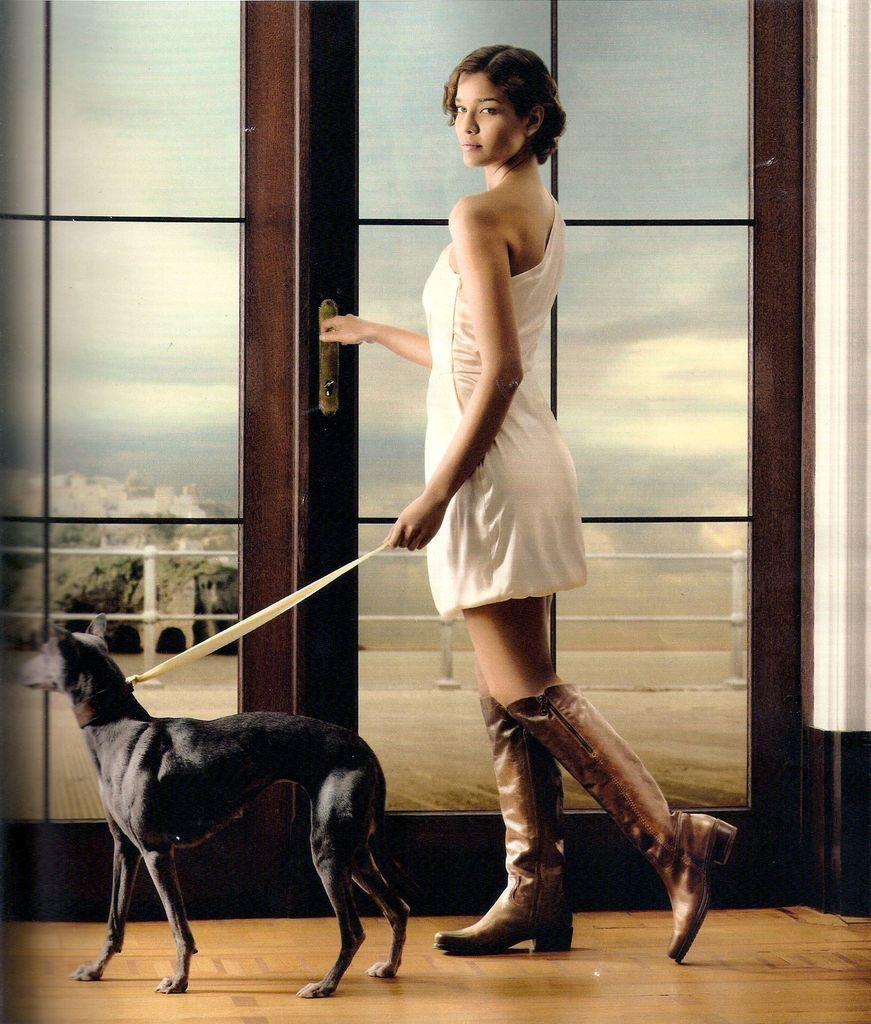What is the main subject in the image? There is a woman standing in the image. Are there any animals present in the image? Yes, there is a dog in the image. What type of architectural feature can be seen in the image? There is a door in the image. What type of silver is being used to glue the plot together in the image? There is no silver, glue, or plot present in the image. 